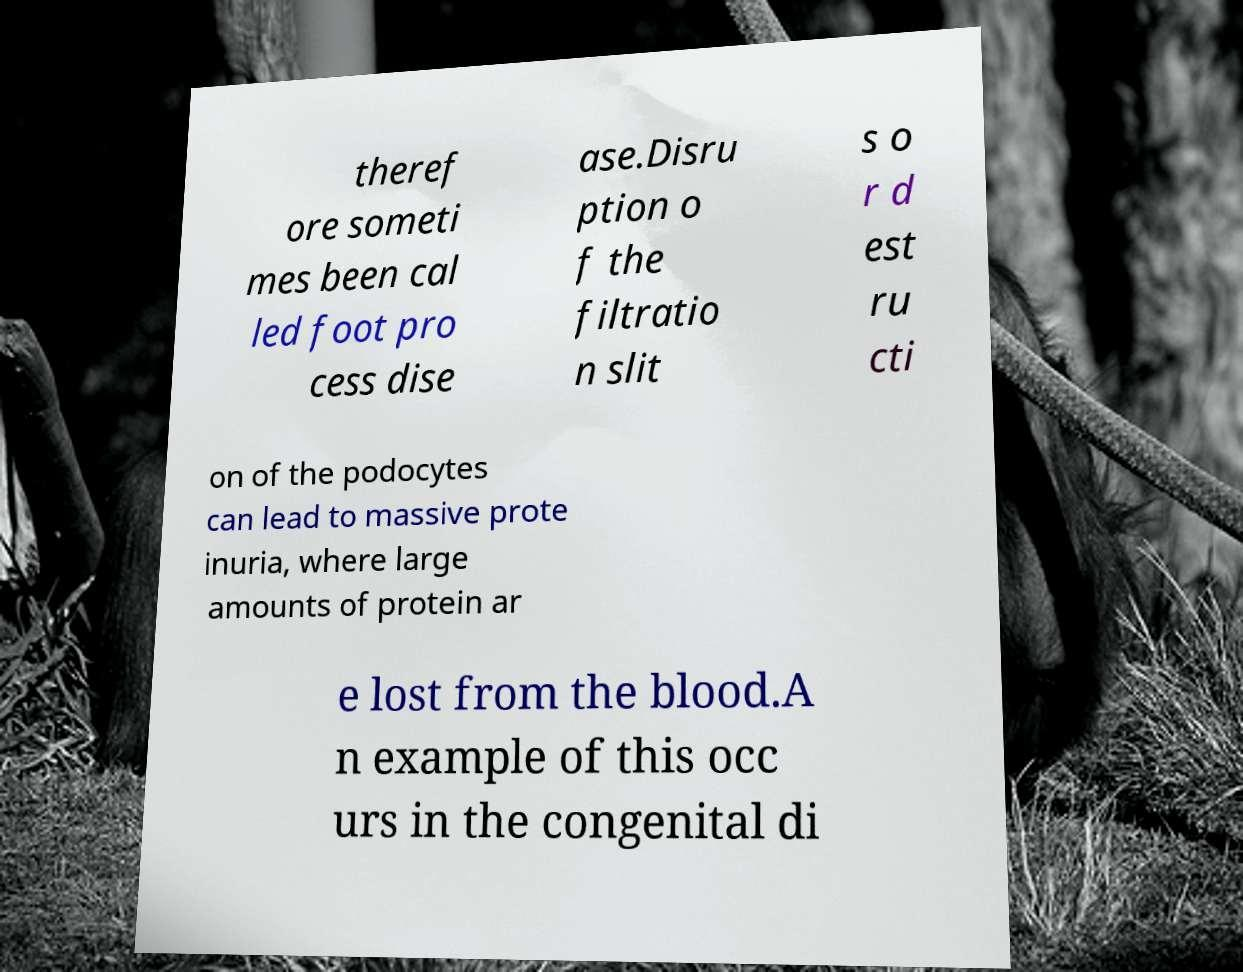Could you assist in decoding the text presented in this image and type it out clearly? theref ore someti mes been cal led foot pro cess dise ase.Disru ption o f the filtratio n slit s o r d est ru cti on of the podocytes can lead to massive prote inuria, where large amounts of protein ar e lost from the blood.A n example of this occ urs in the congenital di 